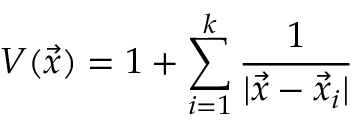<formula> <loc_0><loc_0><loc_500><loc_500>V ( \vec { x } ) = 1 + \sum _ { i = 1 } ^ { k } { \frac { 1 } { | \vec { x } - \vec { x } _ { i } | } }</formula> 